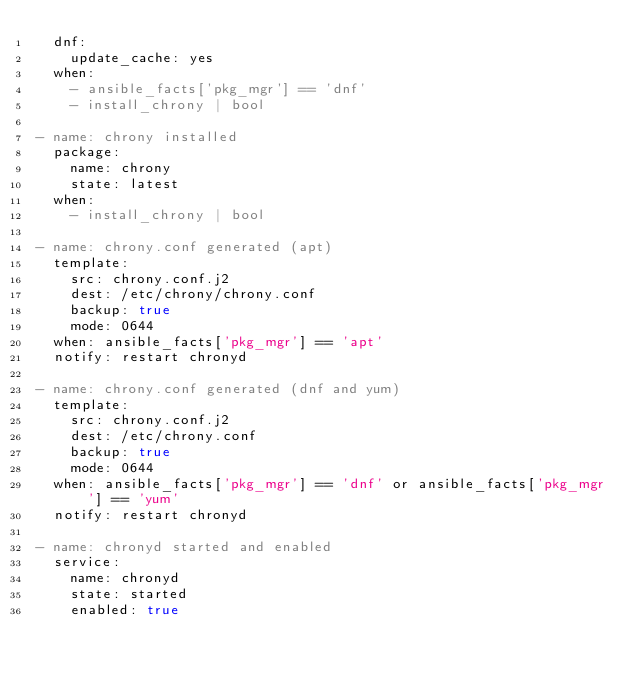Convert code to text. <code><loc_0><loc_0><loc_500><loc_500><_YAML_>  dnf:
    update_cache: yes
  when:
    - ansible_facts['pkg_mgr'] == 'dnf'
    - install_chrony | bool

- name: chrony installed
  package:
    name: chrony
    state: latest
  when:
    - install_chrony | bool

- name: chrony.conf generated (apt)
  template:
    src: chrony.conf.j2
    dest: /etc/chrony/chrony.conf
    backup: true
    mode: 0644
  when: ansible_facts['pkg_mgr'] == 'apt'
  notify: restart chronyd

- name: chrony.conf generated (dnf and yum)
  template:
    src: chrony.conf.j2
    dest: /etc/chrony.conf
    backup: true
    mode: 0644
  when: ansible_facts['pkg_mgr'] == 'dnf' or ansible_facts['pkg_mgr'] == 'yum'
  notify: restart chronyd

- name: chronyd started and enabled
  service:
    name: chronyd
    state: started
    enabled: true
</code> 